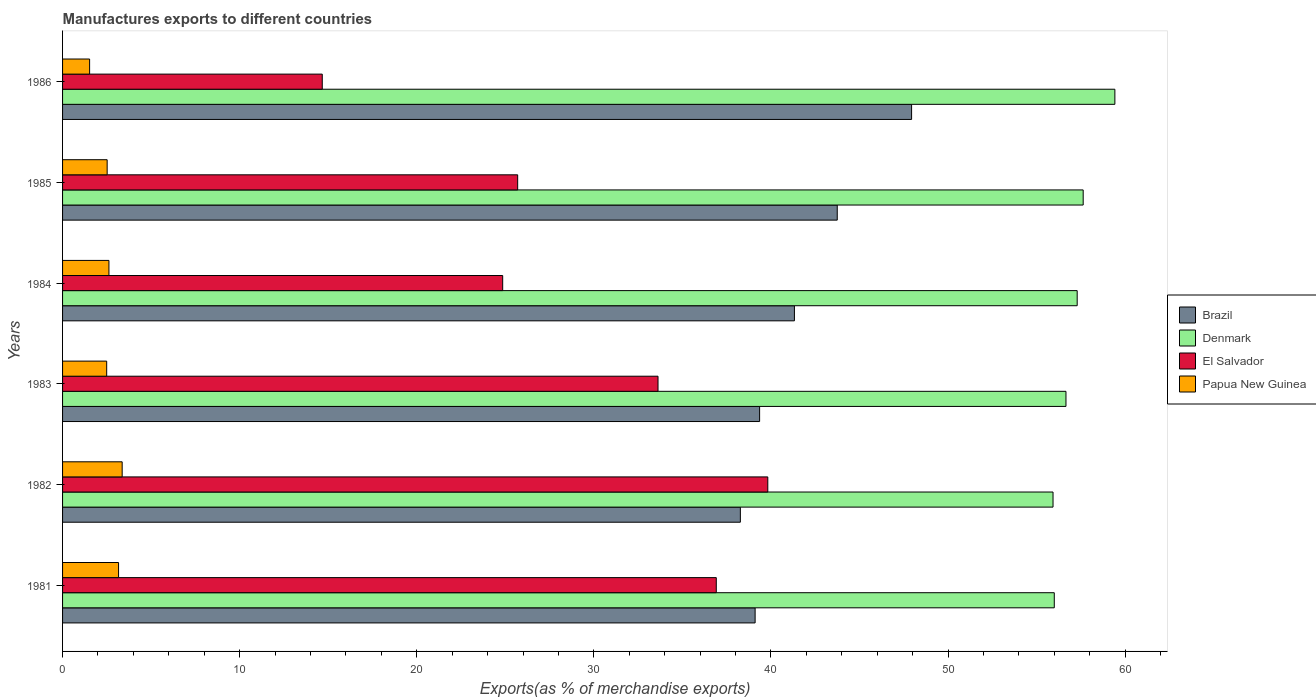How many bars are there on the 6th tick from the bottom?
Make the answer very short. 4. What is the label of the 3rd group of bars from the top?
Ensure brevity in your answer.  1984. In how many cases, is the number of bars for a given year not equal to the number of legend labels?
Your answer should be compact. 0. What is the percentage of exports to different countries in Brazil in 1985?
Your response must be concise. 43.74. Across all years, what is the maximum percentage of exports to different countries in Denmark?
Provide a succinct answer. 59.42. Across all years, what is the minimum percentage of exports to different countries in Papua New Guinea?
Your answer should be compact. 1.53. In which year was the percentage of exports to different countries in Brazil minimum?
Offer a terse response. 1982. What is the total percentage of exports to different countries in Papua New Guinea in the graph?
Your response must be concise. 15.68. What is the difference between the percentage of exports to different countries in Denmark in 1983 and that in 1986?
Ensure brevity in your answer.  -2.76. What is the difference between the percentage of exports to different countries in El Salvador in 1982 and the percentage of exports to different countries in Papua New Guinea in 1986?
Provide a succinct answer. 38.3. What is the average percentage of exports to different countries in Denmark per year?
Offer a terse response. 57.16. In the year 1981, what is the difference between the percentage of exports to different countries in Papua New Guinea and percentage of exports to different countries in Brazil?
Offer a very short reply. -35.95. In how many years, is the percentage of exports to different countries in Papua New Guinea greater than 50 %?
Give a very brief answer. 0. What is the ratio of the percentage of exports to different countries in Papua New Guinea in 1983 to that in 1985?
Make the answer very short. 0.99. Is the percentage of exports to different countries in El Salvador in 1981 less than that in 1983?
Provide a succinct answer. No. What is the difference between the highest and the second highest percentage of exports to different countries in Denmark?
Your answer should be compact. 1.79. What is the difference between the highest and the lowest percentage of exports to different countries in El Salvador?
Make the answer very short. 25.16. In how many years, is the percentage of exports to different countries in El Salvador greater than the average percentage of exports to different countries in El Salvador taken over all years?
Make the answer very short. 3. Is it the case that in every year, the sum of the percentage of exports to different countries in El Salvador and percentage of exports to different countries in Brazil is greater than the sum of percentage of exports to different countries in Denmark and percentage of exports to different countries in Papua New Guinea?
Keep it short and to the point. No. What does the 4th bar from the bottom in 1983 represents?
Make the answer very short. Papua New Guinea. Is it the case that in every year, the sum of the percentage of exports to different countries in Papua New Guinea and percentage of exports to different countries in Brazil is greater than the percentage of exports to different countries in Denmark?
Offer a very short reply. No. How many bars are there?
Make the answer very short. 24. Are all the bars in the graph horizontal?
Provide a succinct answer. Yes. Does the graph contain any zero values?
Your answer should be compact. No. Where does the legend appear in the graph?
Your answer should be very brief. Center right. How many legend labels are there?
Offer a terse response. 4. What is the title of the graph?
Your response must be concise. Manufactures exports to different countries. Does "European Union" appear as one of the legend labels in the graph?
Your answer should be very brief. No. What is the label or title of the X-axis?
Your answer should be very brief. Exports(as % of merchandise exports). What is the label or title of the Y-axis?
Keep it short and to the point. Years. What is the Exports(as % of merchandise exports) of Brazil in 1981?
Keep it short and to the point. 39.11. What is the Exports(as % of merchandise exports) of Denmark in 1981?
Your response must be concise. 56. What is the Exports(as % of merchandise exports) of El Salvador in 1981?
Provide a succinct answer. 36.91. What is the Exports(as % of merchandise exports) of Papua New Guinea in 1981?
Give a very brief answer. 3.16. What is the Exports(as % of merchandise exports) in Brazil in 1982?
Offer a terse response. 38.27. What is the Exports(as % of merchandise exports) of Denmark in 1982?
Your response must be concise. 55.93. What is the Exports(as % of merchandise exports) of El Salvador in 1982?
Keep it short and to the point. 39.82. What is the Exports(as % of merchandise exports) in Papua New Guinea in 1982?
Keep it short and to the point. 3.37. What is the Exports(as % of merchandise exports) of Brazil in 1983?
Make the answer very short. 39.36. What is the Exports(as % of merchandise exports) of Denmark in 1983?
Your answer should be compact. 56.66. What is the Exports(as % of merchandise exports) of El Salvador in 1983?
Provide a succinct answer. 33.62. What is the Exports(as % of merchandise exports) of Papua New Guinea in 1983?
Offer a terse response. 2.49. What is the Exports(as % of merchandise exports) in Brazil in 1984?
Make the answer very short. 41.33. What is the Exports(as % of merchandise exports) in Denmark in 1984?
Make the answer very short. 57.29. What is the Exports(as % of merchandise exports) of El Salvador in 1984?
Make the answer very short. 24.85. What is the Exports(as % of merchandise exports) of Papua New Guinea in 1984?
Provide a succinct answer. 2.62. What is the Exports(as % of merchandise exports) of Brazil in 1985?
Your response must be concise. 43.74. What is the Exports(as % of merchandise exports) in Denmark in 1985?
Offer a terse response. 57.63. What is the Exports(as % of merchandise exports) of El Salvador in 1985?
Your answer should be compact. 25.7. What is the Exports(as % of merchandise exports) of Papua New Guinea in 1985?
Your answer should be very brief. 2.52. What is the Exports(as % of merchandise exports) of Brazil in 1986?
Offer a terse response. 47.94. What is the Exports(as % of merchandise exports) in Denmark in 1986?
Provide a succinct answer. 59.42. What is the Exports(as % of merchandise exports) in El Salvador in 1986?
Offer a very short reply. 14.66. What is the Exports(as % of merchandise exports) in Papua New Guinea in 1986?
Your answer should be compact. 1.53. Across all years, what is the maximum Exports(as % of merchandise exports) of Brazil?
Ensure brevity in your answer.  47.94. Across all years, what is the maximum Exports(as % of merchandise exports) of Denmark?
Offer a very short reply. 59.42. Across all years, what is the maximum Exports(as % of merchandise exports) in El Salvador?
Provide a succinct answer. 39.82. Across all years, what is the maximum Exports(as % of merchandise exports) in Papua New Guinea?
Ensure brevity in your answer.  3.37. Across all years, what is the minimum Exports(as % of merchandise exports) in Brazil?
Your response must be concise. 38.27. Across all years, what is the minimum Exports(as % of merchandise exports) of Denmark?
Offer a terse response. 55.93. Across all years, what is the minimum Exports(as % of merchandise exports) of El Salvador?
Your response must be concise. 14.66. Across all years, what is the minimum Exports(as % of merchandise exports) of Papua New Guinea?
Keep it short and to the point. 1.53. What is the total Exports(as % of merchandise exports) in Brazil in the graph?
Your answer should be very brief. 249.75. What is the total Exports(as % of merchandise exports) of Denmark in the graph?
Offer a terse response. 342.93. What is the total Exports(as % of merchandise exports) of El Salvador in the graph?
Keep it short and to the point. 175.58. What is the total Exports(as % of merchandise exports) of Papua New Guinea in the graph?
Ensure brevity in your answer.  15.68. What is the difference between the Exports(as % of merchandise exports) in Brazil in 1981 and that in 1982?
Offer a very short reply. 0.83. What is the difference between the Exports(as % of merchandise exports) of Denmark in 1981 and that in 1982?
Ensure brevity in your answer.  0.07. What is the difference between the Exports(as % of merchandise exports) in El Salvador in 1981 and that in 1982?
Your answer should be compact. -2.91. What is the difference between the Exports(as % of merchandise exports) of Papua New Guinea in 1981 and that in 1982?
Offer a terse response. -0.2. What is the difference between the Exports(as % of merchandise exports) of Brazil in 1981 and that in 1983?
Make the answer very short. -0.25. What is the difference between the Exports(as % of merchandise exports) of Denmark in 1981 and that in 1983?
Your answer should be compact. -0.66. What is the difference between the Exports(as % of merchandise exports) of El Salvador in 1981 and that in 1983?
Make the answer very short. 3.29. What is the difference between the Exports(as % of merchandise exports) of Papua New Guinea in 1981 and that in 1983?
Your answer should be very brief. 0.67. What is the difference between the Exports(as % of merchandise exports) of Brazil in 1981 and that in 1984?
Your answer should be compact. -2.22. What is the difference between the Exports(as % of merchandise exports) of Denmark in 1981 and that in 1984?
Your answer should be compact. -1.29. What is the difference between the Exports(as % of merchandise exports) in El Salvador in 1981 and that in 1984?
Your answer should be compact. 12.06. What is the difference between the Exports(as % of merchandise exports) in Papua New Guinea in 1981 and that in 1984?
Provide a short and direct response. 0.54. What is the difference between the Exports(as % of merchandise exports) in Brazil in 1981 and that in 1985?
Your response must be concise. -4.64. What is the difference between the Exports(as % of merchandise exports) of Denmark in 1981 and that in 1985?
Provide a succinct answer. -1.63. What is the difference between the Exports(as % of merchandise exports) in El Salvador in 1981 and that in 1985?
Offer a terse response. 11.22. What is the difference between the Exports(as % of merchandise exports) in Papua New Guinea in 1981 and that in 1985?
Your answer should be very brief. 0.64. What is the difference between the Exports(as % of merchandise exports) in Brazil in 1981 and that in 1986?
Provide a short and direct response. -8.84. What is the difference between the Exports(as % of merchandise exports) in Denmark in 1981 and that in 1986?
Your answer should be compact. -3.42. What is the difference between the Exports(as % of merchandise exports) of El Salvador in 1981 and that in 1986?
Make the answer very short. 22.25. What is the difference between the Exports(as % of merchandise exports) of Papua New Guinea in 1981 and that in 1986?
Make the answer very short. 1.63. What is the difference between the Exports(as % of merchandise exports) of Brazil in 1982 and that in 1983?
Make the answer very short. -1.09. What is the difference between the Exports(as % of merchandise exports) in Denmark in 1982 and that in 1983?
Offer a terse response. -0.73. What is the difference between the Exports(as % of merchandise exports) in El Salvador in 1982 and that in 1983?
Offer a very short reply. 6.2. What is the difference between the Exports(as % of merchandise exports) of Papua New Guinea in 1982 and that in 1983?
Provide a succinct answer. 0.87. What is the difference between the Exports(as % of merchandise exports) in Brazil in 1982 and that in 1984?
Provide a succinct answer. -3.05. What is the difference between the Exports(as % of merchandise exports) in Denmark in 1982 and that in 1984?
Your answer should be very brief. -1.36. What is the difference between the Exports(as % of merchandise exports) of El Salvador in 1982 and that in 1984?
Your answer should be compact. 14.97. What is the difference between the Exports(as % of merchandise exports) in Papua New Guinea in 1982 and that in 1984?
Provide a succinct answer. 0.75. What is the difference between the Exports(as % of merchandise exports) of Brazil in 1982 and that in 1985?
Offer a very short reply. -5.47. What is the difference between the Exports(as % of merchandise exports) of Denmark in 1982 and that in 1985?
Offer a terse response. -1.7. What is the difference between the Exports(as % of merchandise exports) in El Salvador in 1982 and that in 1985?
Provide a succinct answer. 14.12. What is the difference between the Exports(as % of merchandise exports) of Papua New Guinea in 1982 and that in 1985?
Keep it short and to the point. 0.85. What is the difference between the Exports(as % of merchandise exports) in Brazil in 1982 and that in 1986?
Provide a short and direct response. -9.67. What is the difference between the Exports(as % of merchandise exports) of Denmark in 1982 and that in 1986?
Make the answer very short. -3.49. What is the difference between the Exports(as % of merchandise exports) of El Salvador in 1982 and that in 1986?
Ensure brevity in your answer.  25.16. What is the difference between the Exports(as % of merchandise exports) of Papua New Guinea in 1982 and that in 1986?
Keep it short and to the point. 1.84. What is the difference between the Exports(as % of merchandise exports) in Brazil in 1983 and that in 1984?
Ensure brevity in your answer.  -1.97. What is the difference between the Exports(as % of merchandise exports) in Denmark in 1983 and that in 1984?
Offer a very short reply. -0.63. What is the difference between the Exports(as % of merchandise exports) in El Salvador in 1983 and that in 1984?
Provide a succinct answer. 8.77. What is the difference between the Exports(as % of merchandise exports) in Papua New Guinea in 1983 and that in 1984?
Provide a short and direct response. -0.13. What is the difference between the Exports(as % of merchandise exports) in Brazil in 1983 and that in 1985?
Your answer should be compact. -4.38. What is the difference between the Exports(as % of merchandise exports) in Denmark in 1983 and that in 1985?
Your answer should be compact. -0.97. What is the difference between the Exports(as % of merchandise exports) in El Salvador in 1983 and that in 1985?
Give a very brief answer. 7.92. What is the difference between the Exports(as % of merchandise exports) in Papua New Guinea in 1983 and that in 1985?
Keep it short and to the point. -0.03. What is the difference between the Exports(as % of merchandise exports) of Brazil in 1983 and that in 1986?
Provide a short and direct response. -8.58. What is the difference between the Exports(as % of merchandise exports) of Denmark in 1983 and that in 1986?
Your answer should be very brief. -2.76. What is the difference between the Exports(as % of merchandise exports) of El Salvador in 1983 and that in 1986?
Provide a succinct answer. 18.96. What is the difference between the Exports(as % of merchandise exports) in Brazil in 1984 and that in 1985?
Your answer should be compact. -2.42. What is the difference between the Exports(as % of merchandise exports) in Denmark in 1984 and that in 1985?
Make the answer very short. -0.34. What is the difference between the Exports(as % of merchandise exports) in El Salvador in 1984 and that in 1985?
Provide a short and direct response. -0.85. What is the difference between the Exports(as % of merchandise exports) of Papua New Guinea in 1984 and that in 1985?
Offer a very short reply. 0.1. What is the difference between the Exports(as % of merchandise exports) in Brazil in 1984 and that in 1986?
Keep it short and to the point. -6.62. What is the difference between the Exports(as % of merchandise exports) in Denmark in 1984 and that in 1986?
Provide a short and direct response. -2.13. What is the difference between the Exports(as % of merchandise exports) of El Salvador in 1984 and that in 1986?
Keep it short and to the point. 10.19. What is the difference between the Exports(as % of merchandise exports) of Papua New Guinea in 1984 and that in 1986?
Provide a succinct answer. 1.09. What is the difference between the Exports(as % of merchandise exports) of Brazil in 1985 and that in 1986?
Provide a short and direct response. -4.2. What is the difference between the Exports(as % of merchandise exports) in Denmark in 1985 and that in 1986?
Keep it short and to the point. -1.79. What is the difference between the Exports(as % of merchandise exports) in El Salvador in 1985 and that in 1986?
Your answer should be very brief. 11.03. What is the difference between the Exports(as % of merchandise exports) in Papua New Guinea in 1985 and that in 1986?
Your answer should be compact. 0.99. What is the difference between the Exports(as % of merchandise exports) in Brazil in 1981 and the Exports(as % of merchandise exports) in Denmark in 1982?
Offer a very short reply. -16.82. What is the difference between the Exports(as % of merchandise exports) of Brazil in 1981 and the Exports(as % of merchandise exports) of El Salvador in 1982?
Ensure brevity in your answer.  -0.72. What is the difference between the Exports(as % of merchandise exports) in Brazil in 1981 and the Exports(as % of merchandise exports) in Papua New Guinea in 1982?
Offer a very short reply. 35.74. What is the difference between the Exports(as % of merchandise exports) in Denmark in 1981 and the Exports(as % of merchandise exports) in El Salvador in 1982?
Your response must be concise. 16.18. What is the difference between the Exports(as % of merchandise exports) in Denmark in 1981 and the Exports(as % of merchandise exports) in Papua New Guinea in 1982?
Make the answer very short. 52.63. What is the difference between the Exports(as % of merchandise exports) in El Salvador in 1981 and the Exports(as % of merchandise exports) in Papua New Guinea in 1982?
Provide a succinct answer. 33.55. What is the difference between the Exports(as % of merchandise exports) of Brazil in 1981 and the Exports(as % of merchandise exports) of Denmark in 1983?
Make the answer very short. -17.55. What is the difference between the Exports(as % of merchandise exports) of Brazil in 1981 and the Exports(as % of merchandise exports) of El Salvador in 1983?
Ensure brevity in your answer.  5.48. What is the difference between the Exports(as % of merchandise exports) of Brazil in 1981 and the Exports(as % of merchandise exports) of Papua New Guinea in 1983?
Your answer should be compact. 36.62. What is the difference between the Exports(as % of merchandise exports) of Denmark in 1981 and the Exports(as % of merchandise exports) of El Salvador in 1983?
Give a very brief answer. 22.38. What is the difference between the Exports(as % of merchandise exports) in Denmark in 1981 and the Exports(as % of merchandise exports) in Papua New Guinea in 1983?
Give a very brief answer. 53.51. What is the difference between the Exports(as % of merchandise exports) of El Salvador in 1981 and the Exports(as % of merchandise exports) of Papua New Guinea in 1983?
Keep it short and to the point. 34.42. What is the difference between the Exports(as % of merchandise exports) of Brazil in 1981 and the Exports(as % of merchandise exports) of Denmark in 1984?
Make the answer very short. -18.19. What is the difference between the Exports(as % of merchandise exports) of Brazil in 1981 and the Exports(as % of merchandise exports) of El Salvador in 1984?
Your response must be concise. 14.25. What is the difference between the Exports(as % of merchandise exports) in Brazil in 1981 and the Exports(as % of merchandise exports) in Papua New Guinea in 1984?
Offer a terse response. 36.49. What is the difference between the Exports(as % of merchandise exports) in Denmark in 1981 and the Exports(as % of merchandise exports) in El Salvador in 1984?
Offer a terse response. 31.15. What is the difference between the Exports(as % of merchandise exports) in Denmark in 1981 and the Exports(as % of merchandise exports) in Papua New Guinea in 1984?
Give a very brief answer. 53.38. What is the difference between the Exports(as % of merchandise exports) in El Salvador in 1981 and the Exports(as % of merchandise exports) in Papua New Guinea in 1984?
Offer a very short reply. 34.29. What is the difference between the Exports(as % of merchandise exports) in Brazil in 1981 and the Exports(as % of merchandise exports) in Denmark in 1985?
Offer a terse response. -18.53. What is the difference between the Exports(as % of merchandise exports) of Brazil in 1981 and the Exports(as % of merchandise exports) of El Salvador in 1985?
Give a very brief answer. 13.41. What is the difference between the Exports(as % of merchandise exports) in Brazil in 1981 and the Exports(as % of merchandise exports) in Papua New Guinea in 1985?
Keep it short and to the point. 36.59. What is the difference between the Exports(as % of merchandise exports) in Denmark in 1981 and the Exports(as % of merchandise exports) in El Salvador in 1985?
Ensure brevity in your answer.  30.3. What is the difference between the Exports(as % of merchandise exports) in Denmark in 1981 and the Exports(as % of merchandise exports) in Papua New Guinea in 1985?
Your answer should be compact. 53.48. What is the difference between the Exports(as % of merchandise exports) of El Salvador in 1981 and the Exports(as % of merchandise exports) of Papua New Guinea in 1985?
Ensure brevity in your answer.  34.4. What is the difference between the Exports(as % of merchandise exports) in Brazil in 1981 and the Exports(as % of merchandise exports) in Denmark in 1986?
Ensure brevity in your answer.  -20.31. What is the difference between the Exports(as % of merchandise exports) in Brazil in 1981 and the Exports(as % of merchandise exports) in El Salvador in 1986?
Keep it short and to the point. 24.44. What is the difference between the Exports(as % of merchandise exports) of Brazil in 1981 and the Exports(as % of merchandise exports) of Papua New Guinea in 1986?
Your answer should be compact. 37.58. What is the difference between the Exports(as % of merchandise exports) of Denmark in 1981 and the Exports(as % of merchandise exports) of El Salvador in 1986?
Offer a very short reply. 41.34. What is the difference between the Exports(as % of merchandise exports) of Denmark in 1981 and the Exports(as % of merchandise exports) of Papua New Guinea in 1986?
Offer a very short reply. 54.47. What is the difference between the Exports(as % of merchandise exports) of El Salvador in 1981 and the Exports(as % of merchandise exports) of Papua New Guinea in 1986?
Give a very brief answer. 35.39. What is the difference between the Exports(as % of merchandise exports) in Brazil in 1982 and the Exports(as % of merchandise exports) in Denmark in 1983?
Make the answer very short. -18.39. What is the difference between the Exports(as % of merchandise exports) of Brazil in 1982 and the Exports(as % of merchandise exports) of El Salvador in 1983?
Provide a short and direct response. 4.65. What is the difference between the Exports(as % of merchandise exports) of Brazil in 1982 and the Exports(as % of merchandise exports) of Papua New Guinea in 1983?
Ensure brevity in your answer.  35.78. What is the difference between the Exports(as % of merchandise exports) in Denmark in 1982 and the Exports(as % of merchandise exports) in El Salvador in 1983?
Give a very brief answer. 22.31. What is the difference between the Exports(as % of merchandise exports) of Denmark in 1982 and the Exports(as % of merchandise exports) of Papua New Guinea in 1983?
Offer a very short reply. 53.44. What is the difference between the Exports(as % of merchandise exports) of El Salvador in 1982 and the Exports(as % of merchandise exports) of Papua New Guinea in 1983?
Provide a short and direct response. 37.33. What is the difference between the Exports(as % of merchandise exports) of Brazil in 1982 and the Exports(as % of merchandise exports) of Denmark in 1984?
Provide a succinct answer. -19.02. What is the difference between the Exports(as % of merchandise exports) of Brazil in 1982 and the Exports(as % of merchandise exports) of El Salvador in 1984?
Your answer should be very brief. 13.42. What is the difference between the Exports(as % of merchandise exports) of Brazil in 1982 and the Exports(as % of merchandise exports) of Papua New Guinea in 1984?
Keep it short and to the point. 35.65. What is the difference between the Exports(as % of merchandise exports) of Denmark in 1982 and the Exports(as % of merchandise exports) of El Salvador in 1984?
Ensure brevity in your answer.  31.08. What is the difference between the Exports(as % of merchandise exports) of Denmark in 1982 and the Exports(as % of merchandise exports) of Papua New Guinea in 1984?
Offer a terse response. 53.31. What is the difference between the Exports(as % of merchandise exports) in El Salvador in 1982 and the Exports(as % of merchandise exports) in Papua New Guinea in 1984?
Your answer should be very brief. 37.2. What is the difference between the Exports(as % of merchandise exports) in Brazil in 1982 and the Exports(as % of merchandise exports) in Denmark in 1985?
Keep it short and to the point. -19.36. What is the difference between the Exports(as % of merchandise exports) in Brazil in 1982 and the Exports(as % of merchandise exports) in El Salvador in 1985?
Provide a succinct answer. 12.57. What is the difference between the Exports(as % of merchandise exports) of Brazil in 1982 and the Exports(as % of merchandise exports) of Papua New Guinea in 1985?
Provide a short and direct response. 35.76. What is the difference between the Exports(as % of merchandise exports) of Denmark in 1982 and the Exports(as % of merchandise exports) of El Salvador in 1985?
Provide a succinct answer. 30.23. What is the difference between the Exports(as % of merchandise exports) in Denmark in 1982 and the Exports(as % of merchandise exports) in Papua New Guinea in 1985?
Give a very brief answer. 53.41. What is the difference between the Exports(as % of merchandise exports) in El Salvador in 1982 and the Exports(as % of merchandise exports) in Papua New Guinea in 1985?
Keep it short and to the point. 37.3. What is the difference between the Exports(as % of merchandise exports) in Brazil in 1982 and the Exports(as % of merchandise exports) in Denmark in 1986?
Keep it short and to the point. -21.15. What is the difference between the Exports(as % of merchandise exports) of Brazil in 1982 and the Exports(as % of merchandise exports) of El Salvador in 1986?
Ensure brevity in your answer.  23.61. What is the difference between the Exports(as % of merchandise exports) in Brazil in 1982 and the Exports(as % of merchandise exports) in Papua New Guinea in 1986?
Offer a terse response. 36.75. What is the difference between the Exports(as % of merchandise exports) in Denmark in 1982 and the Exports(as % of merchandise exports) in El Salvador in 1986?
Your answer should be very brief. 41.26. What is the difference between the Exports(as % of merchandise exports) in Denmark in 1982 and the Exports(as % of merchandise exports) in Papua New Guinea in 1986?
Keep it short and to the point. 54.4. What is the difference between the Exports(as % of merchandise exports) in El Salvador in 1982 and the Exports(as % of merchandise exports) in Papua New Guinea in 1986?
Keep it short and to the point. 38.3. What is the difference between the Exports(as % of merchandise exports) of Brazil in 1983 and the Exports(as % of merchandise exports) of Denmark in 1984?
Offer a terse response. -17.93. What is the difference between the Exports(as % of merchandise exports) of Brazil in 1983 and the Exports(as % of merchandise exports) of El Salvador in 1984?
Offer a terse response. 14.51. What is the difference between the Exports(as % of merchandise exports) in Brazil in 1983 and the Exports(as % of merchandise exports) in Papua New Guinea in 1984?
Offer a very short reply. 36.74. What is the difference between the Exports(as % of merchandise exports) in Denmark in 1983 and the Exports(as % of merchandise exports) in El Salvador in 1984?
Your answer should be compact. 31.81. What is the difference between the Exports(as % of merchandise exports) of Denmark in 1983 and the Exports(as % of merchandise exports) of Papua New Guinea in 1984?
Your answer should be compact. 54.04. What is the difference between the Exports(as % of merchandise exports) of El Salvador in 1983 and the Exports(as % of merchandise exports) of Papua New Guinea in 1984?
Provide a short and direct response. 31. What is the difference between the Exports(as % of merchandise exports) in Brazil in 1983 and the Exports(as % of merchandise exports) in Denmark in 1985?
Your answer should be very brief. -18.27. What is the difference between the Exports(as % of merchandise exports) in Brazil in 1983 and the Exports(as % of merchandise exports) in El Salvador in 1985?
Offer a very short reply. 13.66. What is the difference between the Exports(as % of merchandise exports) of Brazil in 1983 and the Exports(as % of merchandise exports) of Papua New Guinea in 1985?
Provide a short and direct response. 36.84. What is the difference between the Exports(as % of merchandise exports) of Denmark in 1983 and the Exports(as % of merchandise exports) of El Salvador in 1985?
Your answer should be compact. 30.96. What is the difference between the Exports(as % of merchandise exports) of Denmark in 1983 and the Exports(as % of merchandise exports) of Papua New Guinea in 1985?
Offer a terse response. 54.14. What is the difference between the Exports(as % of merchandise exports) in El Salvador in 1983 and the Exports(as % of merchandise exports) in Papua New Guinea in 1985?
Your response must be concise. 31.11. What is the difference between the Exports(as % of merchandise exports) of Brazil in 1983 and the Exports(as % of merchandise exports) of Denmark in 1986?
Provide a short and direct response. -20.06. What is the difference between the Exports(as % of merchandise exports) of Brazil in 1983 and the Exports(as % of merchandise exports) of El Salvador in 1986?
Keep it short and to the point. 24.7. What is the difference between the Exports(as % of merchandise exports) of Brazil in 1983 and the Exports(as % of merchandise exports) of Papua New Guinea in 1986?
Your response must be concise. 37.83. What is the difference between the Exports(as % of merchandise exports) of Denmark in 1983 and the Exports(as % of merchandise exports) of El Salvador in 1986?
Make the answer very short. 42. What is the difference between the Exports(as % of merchandise exports) of Denmark in 1983 and the Exports(as % of merchandise exports) of Papua New Guinea in 1986?
Provide a short and direct response. 55.13. What is the difference between the Exports(as % of merchandise exports) in El Salvador in 1983 and the Exports(as % of merchandise exports) in Papua New Guinea in 1986?
Your response must be concise. 32.1. What is the difference between the Exports(as % of merchandise exports) of Brazil in 1984 and the Exports(as % of merchandise exports) of Denmark in 1985?
Offer a very short reply. -16.31. What is the difference between the Exports(as % of merchandise exports) of Brazil in 1984 and the Exports(as % of merchandise exports) of El Salvador in 1985?
Make the answer very short. 15.63. What is the difference between the Exports(as % of merchandise exports) of Brazil in 1984 and the Exports(as % of merchandise exports) of Papua New Guinea in 1985?
Offer a very short reply. 38.81. What is the difference between the Exports(as % of merchandise exports) of Denmark in 1984 and the Exports(as % of merchandise exports) of El Salvador in 1985?
Offer a very short reply. 31.59. What is the difference between the Exports(as % of merchandise exports) in Denmark in 1984 and the Exports(as % of merchandise exports) in Papua New Guinea in 1985?
Provide a short and direct response. 54.77. What is the difference between the Exports(as % of merchandise exports) of El Salvador in 1984 and the Exports(as % of merchandise exports) of Papua New Guinea in 1985?
Your answer should be very brief. 22.33. What is the difference between the Exports(as % of merchandise exports) of Brazil in 1984 and the Exports(as % of merchandise exports) of Denmark in 1986?
Provide a short and direct response. -18.09. What is the difference between the Exports(as % of merchandise exports) in Brazil in 1984 and the Exports(as % of merchandise exports) in El Salvador in 1986?
Offer a terse response. 26.66. What is the difference between the Exports(as % of merchandise exports) in Brazil in 1984 and the Exports(as % of merchandise exports) in Papua New Guinea in 1986?
Offer a very short reply. 39.8. What is the difference between the Exports(as % of merchandise exports) in Denmark in 1984 and the Exports(as % of merchandise exports) in El Salvador in 1986?
Ensure brevity in your answer.  42.63. What is the difference between the Exports(as % of merchandise exports) in Denmark in 1984 and the Exports(as % of merchandise exports) in Papua New Guinea in 1986?
Keep it short and to the point. 55.77. What is the difference between the Exports(as % of merchandise exports) in El Salvador in 1984 and the Exports(as % of merchandise exports) in Papua New Guinea in 1986?
Offer a terse response. 23.33. What is the difference between the Exports(as % of merchandise exports) in Brazil in 1985 and the Exports(as % of merchandise exports) in Denmark in 1986?
Make the answer very short. -15.68. What is the difference between the Exports(as % of merchandise exports) in Brazil in 1985 and the Exports(as % of merchandise exports) in El Salvador in 1986?
Offer a terse response. 29.08. What is the difference between the Exports(as % of merchandise exports) in Brazil in 1985 and the Exports(as % of merchandise exports) in Papua New Guinea in 1986?
Give a very brief answer. 42.22. What is the difference between the Exports(as % of merchandise exports) in Denmark in 1985 and the Exports(as % of merchandise exports) in El Salvador in 1986?
Your answer should be compact. 42.97. What is the difference between the Exports(as % of merchandise exports) of Denmark in 1985 and the Exports(as % of merchandise exports) of Papua New Guinea in 1986?
Your answer should be compact. 56.11. What is the difference between the Exports(as % of merchandise exports) in El Salvador in 1985 and the Exports(as % of merchandise exports) in Papua New Guinea in 1986?
Give a very brief answer. 24.17. What is the average Exports(as % of merchandise exports) of Brazil per year?
Provide a short and direct response. 41.63. What is the average Exports(as % of merchandise exports) of Denmark per year?
Provide a succinct answer. 57.16. What is the average Exports(as % of merchandise exports) in El Salvador per year?
Your answer should be very brief. 29.26. What is the average Exports(as % of merchandise exports) in Papua New Guinea per year?
Your answer should be compact. 2.61. In the year 1981, what is the difference between the Exports(as % of merchandise exports) of Brazil and Exports(as % of merchandise exports) of Denmark?
Ensure brevity in your answer.  -16.89. In the year 1981, what is the difference between the Exports(as % of merchandise exports) of Brazil and Exports(as % of merchandise exports) of El Salvador?
Your response must be concise. 2.19. In the year 1981, what is the difference between the Exports(as % of merchandise exports) of Brazil and Exports(as % of merchandise exports) of Papua New Guinea?
Offer a terse response. 35.95. In the year 1981, what is the difference between the Exports(as % of merchandise exports) of Denmark and Exports(as % of merchandise exports) of El Salvador?
Provide a succinct answer. 19.09. In the year 1981, what is the difference between the Exports(as % of merchandise exports) of Denmark and Exports(as % of merchandise exports) of Papua New Guinea?
Keep it short and to the point. 52.84. In the year 1981, what is the difference between the Exports(as % of merchandise exports) in El Salvador and Exports(as % of merchandise exports) in Papua New Guinea?
Ensure brevity in your answer.  33.75. In the year 1982, what is the difference between the Exports(as % of merchandise exports) in Brazil and Exports(as % of merchandise exports) in Denmark?
Keep it short and to the point. -17.66. In the year 1982, what is the difference between the Exports(as % of merchandise exports) of Brazil and Exports(as % of merchandise exports) of El Salvador?
Your response must be concise. -1.55. In the year 1982, what is the difference between the Exports(as % of merchandise exports) in Brazil and Exports(as % of merchandise exports) in Papua New Guinea?
Give a very brief answer. 34.91. In the year 1982, what is the difference between the Exports(as % of merchandise exports) of Denmark and Exports(as % of merchandise exports) of El Salvador?
Your response must be concise. 16.11. In the year 1982, what is the difference between the Exports(as % of merchandise exports) in Denmark and Exports(as % of merchandise exports) in Papua New Guinea?
Keep it short and to the point. 52.56. In the year 1982, what is the difference between the Exports(as % of merchandise exports) in El Salvador and Exports(as % of merchandise exports) in Papua New Guinea?
Provide a short and direct response. 36.46. In the year 1983, what is the difference between the Exports(as % of merchandise exports) in Brazil and Exports(as % of merchandise exports) in Denmark?
Your response must be concise. -17.3. In the year 1983, what is the difference between the Exports(as % of merchandise exports) of Brazil and Exports(as % of merchandise exports) of El Salvador?
Offer a very short reply. 5.74. In the year 1983, what is the difference between the Exports(as % of merchandise exports) of Brazil and Exports(as % of merchandise exports) of Papua New Guinea?
Your response must be concise. 36.87. In the year 1983, what is the difference between the Exports(as % of merchandise exports) of Denmark and Exports(as % of merchandise exports) of El Salvador?
Offer a terse response. 23.04. In the year 1983, what is the difference between the Exports(as % of merchandise exports) in Denmark and Exports(as % of merchandise exports) in Papua New Guinea?
Your response must be concise. 54.17. In the year 1983, what is the difference between the Exports(as % of merchandise exports) in El Salvador and Exports(as % of merchandise exports) in Papua New Guinea?
Give a very brief answer. 31.13. In the year 1984, what is the difference between the Exports(as % of merchandise exports) of Brazil and Exports(as % of merchandise exports) of Denmark?
Provide a short and direct response. -15.97. In the year 1984, what is the difference between the Exports(as % of merchandise exports) in Brazil and Exports(as % of merchandise exports) in El Salvador?
Make the answer very short. 16.47. In the year 1984, what is the difference between the Exports(as % of merchandise exports) in Brazil and Exports(as % of merchandise exports) in Papua New Guinea?
Provide a short and direct response. 38.71. In the year 1984, what is the difference between the Exports(as % of merchandise exports) of Denmark and Exports(as % of merchandise exports) of El Salvador?
Offer a terse response. 32.44. In the year 1984, what is the difference between the Exports(as % of merchandise exports) in Denmark and Exports(as % of merchandise exports) in Papua New Guinea?
Your answer should be compact. 54.67. In the year 1984, what is the difference between the Exports(as % of merchandise exports) of El Salvador and Exports(as % of merchandise exports) of Papua New Guinea?
Offer a terse response. 22.23. In the year 1985, what is the difference between the Exports(as % of merchandise exports) of Brazil and Exports(as % of merchandise exports) of Denmark?
Make the answer very short. -13.89. In the year 1985, what is the difference between the Exports(as % of merchandise exports) of Brazil and Exports(as % of merchandise exports) of El Salvador?
Offer a terse response. 18.05. In the year 1985, what is the difference between the Exports(as % of merchandise exports) of Brazil and Exports(as % of merchandise exports) of Papua New Guinea?
Offer a terse response. 41.23. In the year 1985, what is the difference between the Exports(as % of merchandise exports) of Denmark and Exports(as % of merchandise exports) of El Salvador?
Your response must be concise. 31.93. In the year 1985, what is the difference between the Exports(as % of merchandise exports) in Denmark and Exports(as % of merchandise exports) in Papua New Guinea?
Offer a terse response. 55.11. In the year 1985, what is the difference between the Exports(as % of merchandise exports) of El Salvador and Exports(as % of merchandise exports) of Papua New Guinea?
Your answer should be very brief. 23.18. In the year 1986, what is the difference between the Exports(as % of merchandise exports) of Brazil and Exports(as % of merchandise exports) of Denmark?
Offer a terse response. -11.48. In the year 1986, what is the difference between the Exports(as % of merchandise exports) of Brazil and Exports(as % of merchandise exports) of El Salvador?
Offer a terse response. 33.28. In the year 1986, what is the difference between the Exports(as % of merchandise exports) in Brazil and Exports(as % of merchandise exports) in Papua New Guinea?
Make the answer very short. 46.42. In the year 1986, what is the difference between the Exports(as % of merchandise exports) of Denmark and Exports(as % of merchandise exports) of El Salvador?
Keep it short and to the point. 44.76. In the year 1986, what is the difference between the Exports(as % of merchandise exports) of Denmark and Exports(as % of merchandise exports) of Papua New Guinea?
Make the answer very short. 57.89. In the year 1986, what is the difference between the Exports(as % of merchandise exports) of El Salvador and Exports(as % of merchandise exports) of Papua New Guinea?
Make the answer very short. 13.14. What is the ratio of the Exports(as % of merchandise exports) in Brazil in 1981 to that in 1982?
Offer a very short reply. 1.02. What is the ratio of the Exports(as % of merchandise exports) of El Salvador in 1981 to that in 1982?
Your answer should be very brief. 0.93. What is the ratio of the Exports(as % of merchandise exports) in Papua New Guinea in 1981 to that in 1982?
Make the answer very short. 0.94. What is the ratio of the Exports(as % of merchandise exports) in Denmark in 1981 to that in 1983?
Give a very brief answer. 0.99. What is the ratio of the Exports(as % of merchandise exports) of El Salvador in 1981 to that in 1983?
Your response must be concise. 1.1. What is the ratio of the Exports(as % of merchandise exports) in Papua New Guinea in 1981 to that in 1983?
Your response must be concise. 1.27. What is the ratio of the Exports(as % of merchandise exports) in Brazil in 1981 to that in 1984?
Your answer should be very brief. 0.95. What is the ratio of the Exports(as % of merchandise exports) of Denmark in 1981 to that in 1984?
Your response must be concise. 0.98. What is the ratio of the Exports(as % of merchandise exports) of El Salvador in 1981 to that in 1984?
Offer a terse response. 1.49. What is the ratio of the Exports(as % of merchandise exports) in Papua New Guinea in 1981 to that in 1984?
Keep it short and to the point. 1.21. What is the ratio of the Exports(as % of merchandise exports) of Brazil in 1981 to that in 1985?
Ensure brevity in your answer.  0.89. What is the ratio of the Exports(as % of merchandise exports) of Denmark in 1981 to that in 1985?
Offer a very short reply. 0.97. What is the ratio of the Exports(as % of merchandise exports) of El Salvador in 1981 to that in 1985?
Your answer should be compact. 1.44. What is the ratio of the Exports(as % of merchandise exports) of Papua New Guinea in 1981 to that in 1985?
Make the answer very short. 1.26. What is the ratio of the Exports(as % of merchandise exports) in Brazil in 1981 to that in 1986?
Offer a very short reply. 0.82. What is the ratio of the Exports(as % of merchandise exports) in Denmark in 1981 to that in 1986?
Offer a very short reply. 0.94. What is the ratio of the Exports(as % of merchandise exports) in El Salvador in 1981 to that in 1986?
Provide a short and direct response. 2.52. What is the ratio of the Exports(as % of merchandise exports) in Papua New Guinea in 1981 to that in 1986?
Provide a succinct answer. 2.07. What is the ratio of the Exports(as % of merchandise exports) of Brazil in 1982 to that in 1983?
Ensure brevity in your answer.  0.97. What is the ratio of the Exports(as % of merchandise exports) of Denmark in 1982 to that in 1983?
Your response must be concise. 0.99. What is the ratio of the Exports(as % of merchandise exports) in El Salvador in 1982 to that in 1983?
Offer a very short reply. 1.18. What is the ratio of the Exports(as % of merchandise exports) in Papua New Guinea in 1982 to that in 1983?
Offer a terse response. 1.35. What is the ratio of the Exports(as % of merchandise exports) in Brazil in 1982 to that in 1984?
Your answer should be compact. 0.93. What is the ratio of the Exports(as % of merchandise exports) in Denmark in 1982 to that in 1984?
Provide a short and direct response. 0.98. What is the ratio of the Exports(as % of merchandise exports) of El Salvador in 1982 to that in 1984?
Offer a very short reply. 1.6. What is the ratio of the Exports(as % of merchandise exports) in Papua New Guinea in 1982 to that in 1984?
Your response must be concise. 1.29. What is the ratio of the Exports(as % of merchandise exports) of Brazil in 1982 to that in 1985?
Provide a succinct answer. 0.87. What is the ratio of the Exports(as % of merchandise exports) in Denmark in 1982 to that in 1985?
Make the answer very short. 0.97. What is the ratio of the Exports(as % of merchandise exports) of El Salvador in 1982 to that in 1985?
Give a very brief answer. 1.55. What is the ratio of the Exports(as % of merchandise exports) in Papua New Guinea in 1982 to that in 1985?
Ensure brevity in your answer.  1.34. What is the ratio of the Exports(as % of merchandise exports) in Brazil in 1982 to that in 1986?
Your answer should be compact. 0.8. What is the ratio of the Exports(as % of merchandise exports) of Denmark in 1982 to that in 1986?
Your answer should be compact. 0.94. What is the ratio of the Exports(as % of merchandise exports) of El Salvador in 1982 to that in 1986?
Make the answer very short. 2.72. What is the ratio of the Exports(as % of merchandise exports) of Papua New Guinea in 1982 to that in 1986?
Give a very brief answer. 2.2. What is the ratio of the Exports(as % of merchandise exports) in Brazil in 1983 to that in 1984?
Your response must be concise. 0.95. What is the ratio of the Exports(as % of merchandise exports) in Denmark in 1983 to that in 1984?
Provide a succinct answer. 0.99. What is the ratio of the Exports(as % of merchandise exports) of El Salvador in 1983 to that in 1984?
Offer a very short reply. 1.35. What is the ratio of the Exports(as % of merchandise exports) of Papua New Guinea in 1983 to that in 1984?
Keep it short and to the point. 0.95. What is the ratio of the Exports(as % of merchandise exports) of Brazil in 1983 to that in 1985?
Offer a terse response. 0.9. What is the ratio of the Exports(as % of merchandise exports) of Denmark in 1983 to that in 1985?
Provide a succinct answer. 0.98. What is the ratio of the Exports(as % of merchandise exports) in El Salvador in 1983 to that in 1985?
Offer a terse response. 1.31. What is the ratio of the Exports(as % of merchandise exports) in Papua New Guinea in 1983 to that in 1985?
Give a very brief answer. 0.99. What is the ratio of the Exports(as % of merchandise exports) of Brazil in 1983 to that in 1986?
Your answer should be compact. 0.82. What is the ratio of the Exports(as % of merchandise exports) in Denmark in 1983 to that in 1986?
Your answer should be very brief. 0.95. What is the ratio of the Exports(as % of merchandise exports) in El Salvador in 1983 to that in 1986?
Give a very brief answer. 2.29. What is the ratio of the Exports(as % of merchandise exports) of Papua New Guinea in 1983 to that in 1986?
Keep it short and to the point. 1.63. What is the ratio of the Exports(as % of merchandise exports) in Brazil in 1984 to that in 1985?
Your answer should be very brief. 0.94. What is the ratio of the Exports(as % of merchandise exports) of Denmark in 1984 to that in 1985?
Offer a terse response. 0.99. What is the ratio of the Exports(as % of merchandise exports) of El Salvador in 1984 to that in 1985?
Keep it short and to the point. 0.97. What is the ratio of the Exports(as % of merchandise exports) in Papua New Guinea in 1984 to that in 1985?
Make the answer very short. 1.04. What is the ratio of the Exports(as % of merchandise exports) of Brazil in 1984 to that in 1986?
Your answer should be very brief. 0.86. What is the ratio of the Exports(as % of merchandise exports) of Denmark in 1984 to that in 1986?
Make the answer very short. 0.96. What is the ratio of the Exports(as % of merchandise exports) of El Salvador in 1984 to that in 1986?
Give a very brief answer. 1.69. What is the ratio of the Exports(as % of merchandise exports) in Papua New Guinea in 1984 to that in 1986?
Provide a short and direct response. 1.72. What is the ratio of the Exports(as % of merchandise exports) in Brazil in 1985 to that in 1986?
Your answer should be very brief. 0.91. What is the ratio of the Exports(as % of merchandise exports) of Denmark in 1985 to that in 1986?
Provide a succinct answer. 0.97. What is the ratio of the Exports(as % of merchandise exports) of El Salvador in 1985 to that in 1986?
Your answer should be very brief. 1.75. What is the ratio of the Exports(as % of merchandise exports) of Papua New Guinea in 1985 to that in 1986?
Give a very brief answer. 1.65. What is the difference between the highest and the second highest Exports(as % of merchandise exports) in Brazil?
Your answer should be compact. 4.2. What is the difference between the highest and the second highest Exports(as % of merchandise exports) of Denmark?
Your response must be concise. 1.79. What is the difference between the highest and the second highest Exports(as % of merchandise exports) of El Salvador?
Offer a very short reply. 2.91. What is the difference between the highest and the second highest Exports(as % of merchandise exports) of Papua New Guinea?
Your response must be concise. 0.2. What is the difference between the highest and the lowest Exports(as % of merchandise exports) in Brazil?
Give a very brief answer. 9.67. What is the difference between the highest and the lowest Exports(as % of merchandise exports) of Denmark?
Offer a very short reply. 3.49. What is the difference between the highest and the lowest Exports(as % of merchandise exports) in El Salvador?
Provide a succinct answer. 25.16. What is the difference between the highest and the lowest Exports(as % of merchandise exports) of Papua New Guinea?
Offer a very short reply. 1.84. 